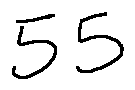Convert formula to latex. <formula><loc_0><loc_0><loc_500><loc_500>5 5</formula> 